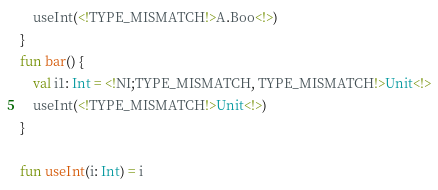Convert code to text. <code><loc_0><loc_0><loc_500><loc_500><_Kotlin_>    useInt(<!TYPE_MISMATCH!>A.Boo<!>)
}
fun bar() {
    val i1: Int = <!NI;TYPE_MISMATCH, TYPE_MISMATCH!>Unit<!>
    useInt(<!TYPE_MISMATCH!>Unit<!>)
}

fun useInt(i: Int) = i
</code> 